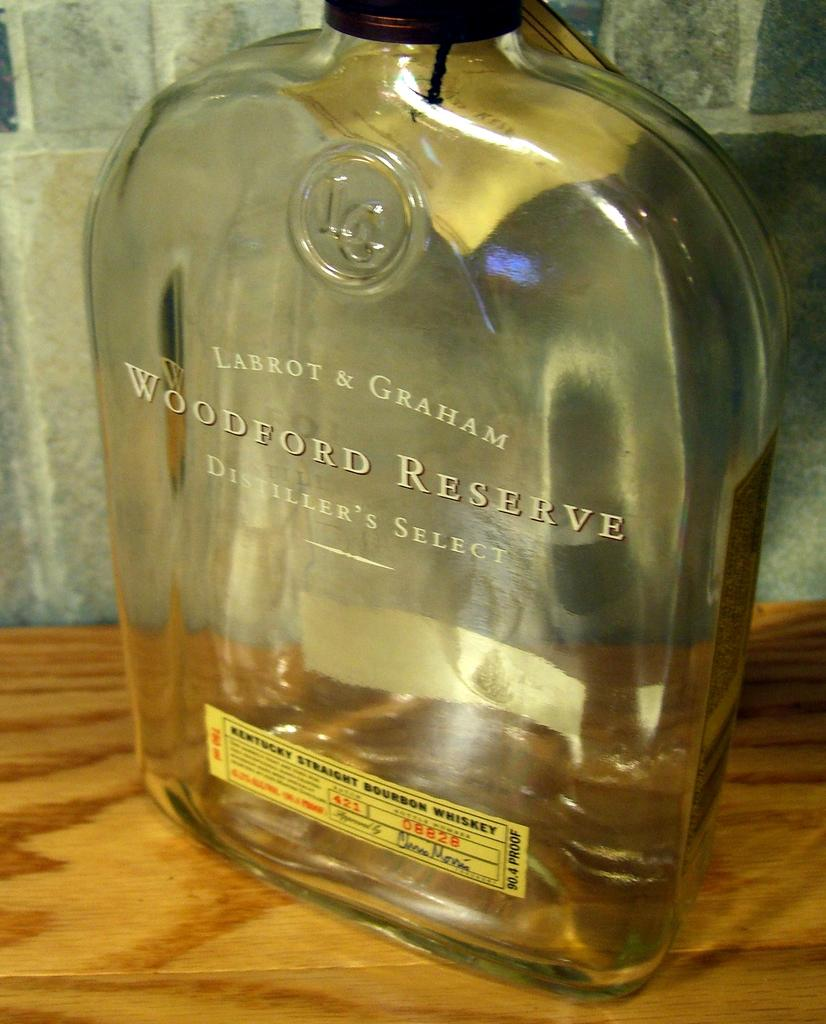<image>
Present a compact description of the photo's key features. an empty bottle of labrot & graham woodford reserve distiller's select 